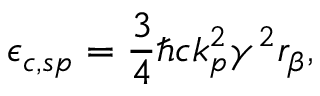Convert formula to latex. <formula><loc_0><loc_0><loc_500><loc_500>\epsilon _ { c , s p } = \frac { 3 } { 4 } \hbar { c } k _ { p } ^ { 2 } \gamma ^ { 2 } r _ { \beta } ,</formula> 